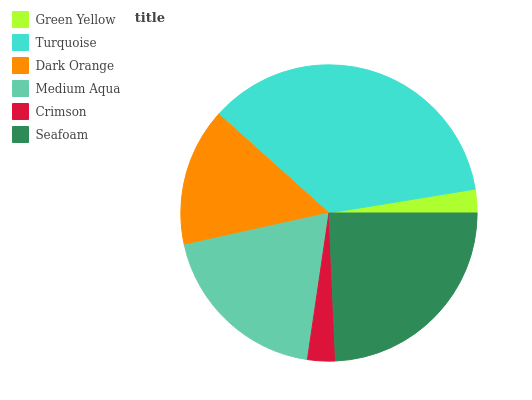Is Green Yellow the minimum?
Answer yes or no. Yes. Is Turquoise the maximum?
Answer yes or no. Yes. Is Dark Orange the minimum?
Answer yes or no. No. Is Dark Orange the maximum?
Answer yes or no. No. Is Turquoise greater than Dark Orange?
Answer yes or no. Yes. Is Dark Orange less than Turquoise?
Answer yes or no. Yes. Is Dark Orange greater than Turquoise?
Answer yes or no. No. Is Turquoise less than Dark Orange?
Answer yes or no. No. Is Medium Aqua the high median?
Answer yes or no. Yes. Is Dark Orange the low median?
Answer yes or no. Yes. Is Dark Orange the high median?
Answer yes or no. No. Is Medium Aqua the low median?
Answer yes or no. No. 